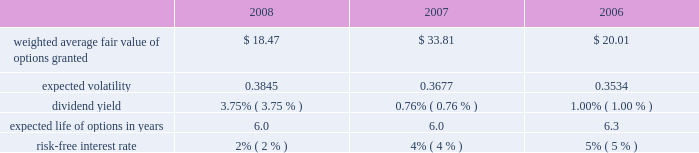
The black-scholes option valuation model was developed for use in estimating the fair value of traded options which have no vesting restrictions and are fully transferable .
In addition , option valuation models require the input of highly subjective assumptions , including the expected stock price volatility .
Because the company 2019s employee stock options have characteristics significantly different from those of traded options , and because changes in the subjective input assumptions can materially affect the fair value estimate , in management 2019s opinion , the existing models do not necessarily provide a reliable single measure of the fair value of its employee stock options .
The fair value of the rsus was determined based on the market value at the date of grant .
The total fair value of awards vested during 2008 , 2007 , and 2006 was $ 35384 , $ 17840 , and $ 9413 , respectively .
The total stock based compensation expense calculated using the black-scholes option valuation model in 2008 , 2007 , and 2006 was $ 38872 , $ 22164 , and $ 11913 , respectively.the aggregate intrinsic values of options outstanding and exercisable at december 27 , 2008 were $ 8.2 million and $ 8.2 million , respectively .
The aggregate intrinsic value of options exercised during the year ended december 27 , 2008 was $ 0.6 million .
Aggregate intrinsic value represents the positive difference between the company 2019s closing stock price on the last trading day of the fiscal period , which was $ 19.39 on december 27 , 2008 , and the exercise price multiplied by the number of options exercised .
As of december 27 , 2008 , there was $ 141.7 million of total unrecognized compensation cost related to unvested share-based compensation awards granted to employees under the stock compensation plans .
That cost is expected to be recognized over a period of five years .
Employee stock purchase plan the shareholders also adopted an employee stock purchase plan ( espp ) .
Up to 2000000 shares of common stock have been reserved for the espp .
Shares will be offered to employees at a price equal to the lesser of 85% ( 85 % ) of the fair market value of the stock on the date of purchase or 85% ( 85 % ) of the fair market value on the enrollment date .
The espp is intended to qualify as an 201cemployee stock purchase plan 201d under section 423 of the internal revenue code .
During 2008 , 2007 , and 2006 , 362902 , 120230 , and 124693 shares , respectively were purchased under the plan for a total purchase price of $ 8782 , $ 5730 , and $ 3569 , respectively .
At december 27 , 2008 , approximately 663679 shares were available for future issuance .
10 .
Earnings per share the following table sets forth the computation of basic and diluted net income per share: .
Considering the fair value of options granted in 2008 , what is going to be its estimated future value when the expected life ends? 
Rationale: it is the future value formula , in which $ 1847 is the present value , 3.75% is the interest rate and 6 years is the period .
Computations: (18.47 * ((1 + 3.75%) ** 6))
Answer: 23.03539. 